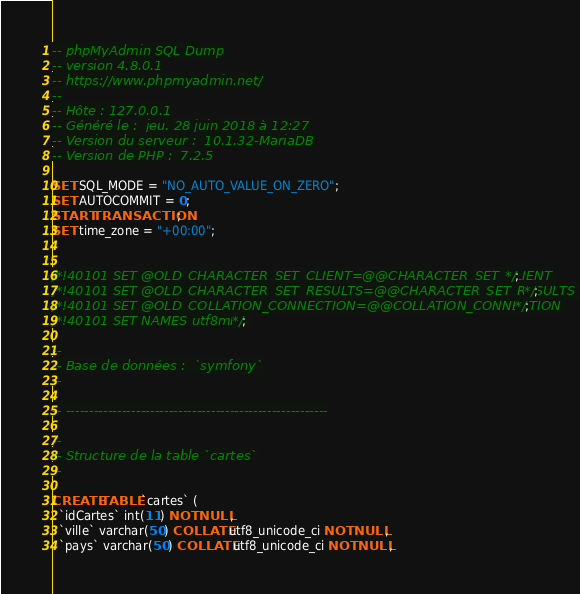<code> <loc_0><loc_0><loc_500><loc_500><_SQL_>-- phpMyAdmin SQL Dump
-- version 4.8.0.1
-- https://www.phpmyadmin.net/
--
-- Hôte : 127.0.0.1
-- Généré le :  jeu. 28 juin 2018 à 12:27
-- Version du serveur :  10.1.32-MariaDB
-- Version de PHP :  7.2.5

SET SQL_MODE = "NO_AUTO_VALUE_ON_ZERO";
SET AUTOCOMMIT = 0;
START TRANSACTION;
SET time_zone = "+00:00";


/*!40101 SET @OLD_CHARACTER_SET_CLIENT=@@CHARACTER_SET_CLIENT */;
/*!40101 SET @OLD_CHARACTER_SET_RESULTS=@@CHARACTER_SET_RESULTS */;
/*!40101 SET @OLD_COLLATION_CONNECTION=@@COLLATION_CONNECTION */;
/*!40101 SET NAMES utf8mb4 */;

--
-- Base de données :  `symfony`
--

-- --------------------------------------------------------

--
-- Structure de la table `cartes`
--

CREATE TABLE `cartes` (
  `idCartes` int(11) NOT NULL,
  `ville` varchar(50) COLLATE utf8_unicode_ci NOT NULL,
  `pays` varchar(50) COLLATE utf8_unicode_ci NOT NULL,</code> 